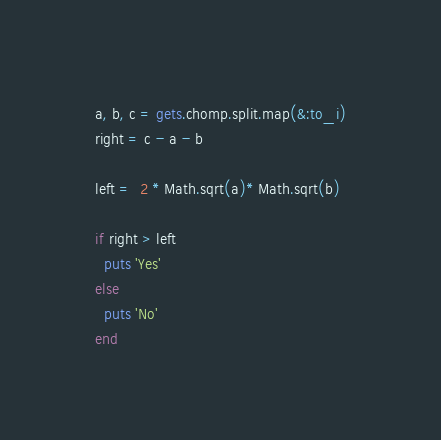Convert code to text. <code><loc_0><loc_0><loc_500><loc_500><_Ruby_>a, b, c = gets.chomp.split.map(&:to_i)
right = c - a - b

left =  2 * Math.sqrt(a)* Math.sqrt(b)

if right > left
  puts 'Yes'
else
  puts 'No'
end</code> 